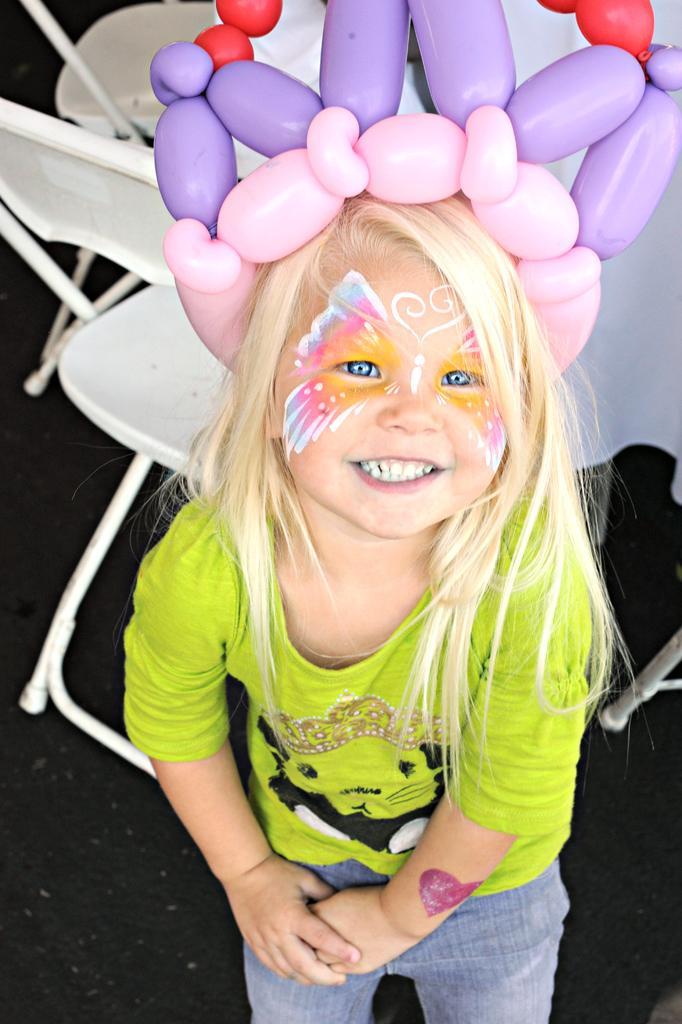Can you describe this image briefly? In the image there is a girl,she is wearing a butterfly tattoo to her face and there is a balloon crown around her head and behind the girl there are some white chairs. 